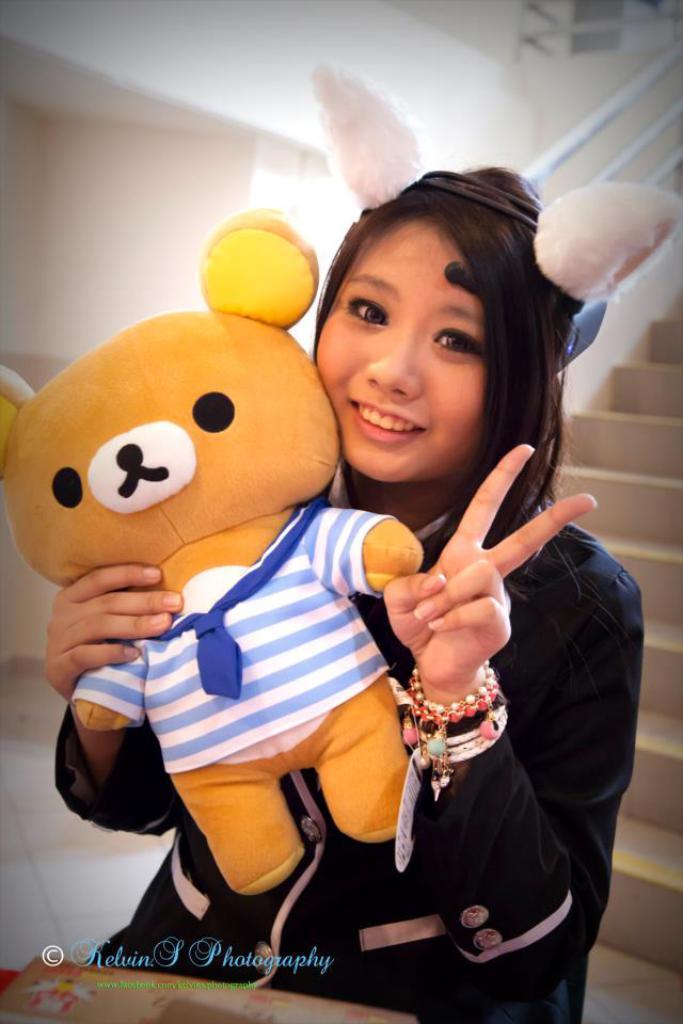How would you summarize this image in a sentence or two? In this picture we can see a woman holding a toy and behind the women there are steps and a wall. On the image there is a watermark. 